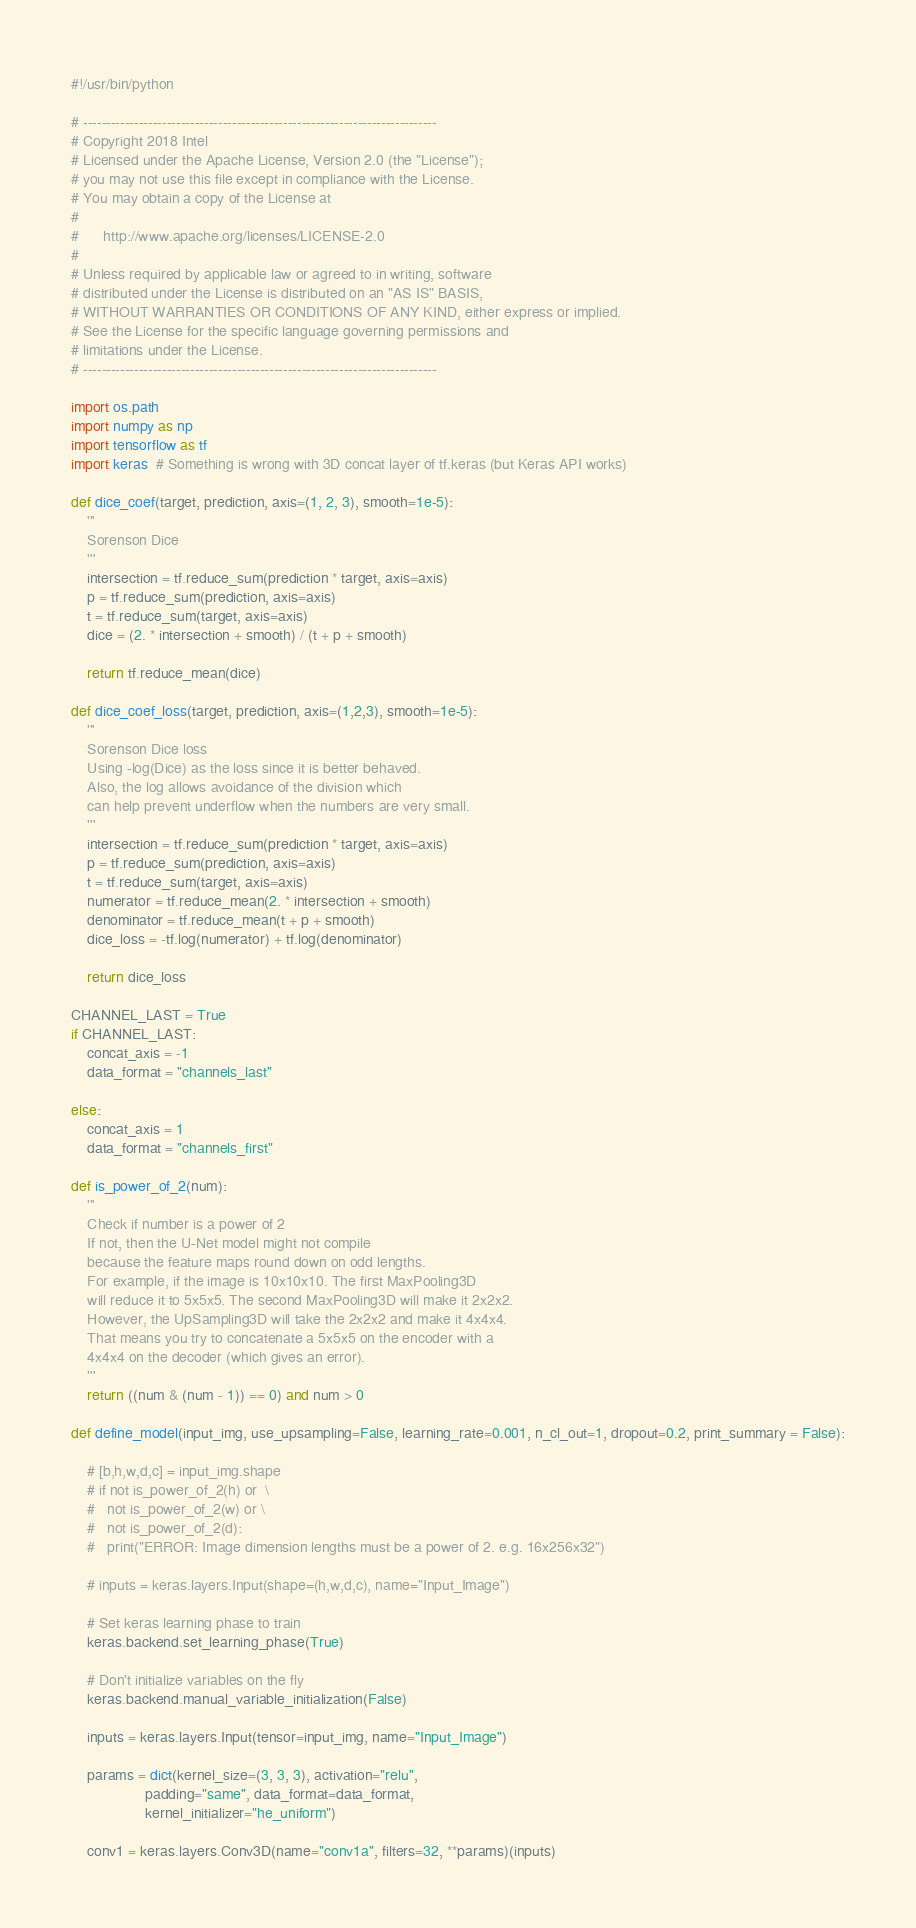<code> <loc_0><loc_0><loc_500><loc_500><_Python_>#!/usr/bin/python

# ----------------------------------------------------------------------------
# Copyright 2018 Intel
# Licensed under the Apache License, Version 2.0 (the "License");
# you may not use this file except in compliance with the License.
# You may obtain a copy of the License at
#
#      http://www.apache.org/licenses/LICENSE-2.0
#
# Unless required by applicable law or agreed to in writing, software
# distributed under the License is distributed on an "AS IS" BASIS,
# WITHOUT WARRANTIES OR CONDITIONS OF ANY KIND, either express or implied.
# See the License for the specific language governing permissions and
# limitations under the License.
# ----------------------------------------------------------------------------

import os.path
import numpy as np
import tensorflow as tf
import keras  # Something is wrong with 3D concat layer of tf.keras (but Keras API works)

def dice_coef(target, prediction, axis=(1, 2, 3), smooth=1e-5):
	'''
	Sorenson Dice
	'''
	intersection = tf.reduce_sum(prediction * target, axis=axis)
	p = tf.reduce_sum(prediction, axis=axis)
	t = tf.reduce_sum(target, axis=axis)
	dice = (2. * intersection + smooth) / (t + p + smooth)

	return tf.reduce_mean(dice)

def dice_coef_loss(target, prediction, axis=(1,2,3), smooth=1e-5):
	'''
	Sorenson Dice loss
	Using -log(Dice) as the loss since it is better behaved.
	Also, the log allows avoidance of the division which
	can help prevent underflow when the numbers are very small.
	'''
	intersection = tf.reduce_sum(prediction * target, axis=axis)
	p = tf.reduce_sum(prediction, axis=axis)
	t = tf.reduce_sum(target, axis=axis)
	numerator = tf.reduce_mean(2. * intersection + smooth)
	denominator = tf.reduce_mean(t + p + smooth)
	dice_loss = -tf.log(numerator) + tf.log(denominator)

	return dice_loss

CHANNEL_LAST = True
if CHANNEL_LAST:
	concat_axis = -1
	data_format = "channels_last"

else:
	concat_axis = 1
	data_format = "channels_first"

def is_power_of_2(num):
	'''
	Check if number is a power of 2
	If not, then the U-Net model might not compile
	because the feature maps round down on odd lengths.
	For example, if the image is 10x10x10. The first MaxPooling3D
	will reduce it to 5x5x5. The second MaxPooling3D will make it 2x2x2.
	However, the UpSampling3D will take the 2x2x2 and make it 4x4x4.
	That means you try to concatenate a 5x5x5 on the encoder with a
	4x4x4 on the decoder (which gives an error).
	'''
	return ((num & (num - 1)) == 0) and num > 0

def define_model(input_img, use_upsampling=False, learning_rate=0.001, n_cl_out=1, dropout=0.2, print_summary = False):

	# [b,h,w,d,c] = input_img.shape
	# if not is_power_of_2(h) or  \
	# 	not is_power_of_2(w) or \
	# 	not is_power_of_2(d):
	# 	print("ERROR: Image dimension lengths must be a power of 2. e.g. 16x256x32")

	# inputs = keras.layers.Input(shape=(h,w,d,c), name="Input_Image")

	# Set keras learning phase to train
	keras.backend.set_learning_phase(True)

	# Don't initialize variables on the fly
	keras.backend.manual_variable_initialization(False)

	inputs = keras.layers.Input(tensor=input_img, name="Input_Image")

	params = dict(kernel_size=(3, 3, 3), activation="relu",
				  padding="same", data_format=data_format,
				  kernel_initializer="he_uniform")

	conv1 = keras.layers.Conv3D(name="conv1a", filters=32, **params)(inputs)</code> 